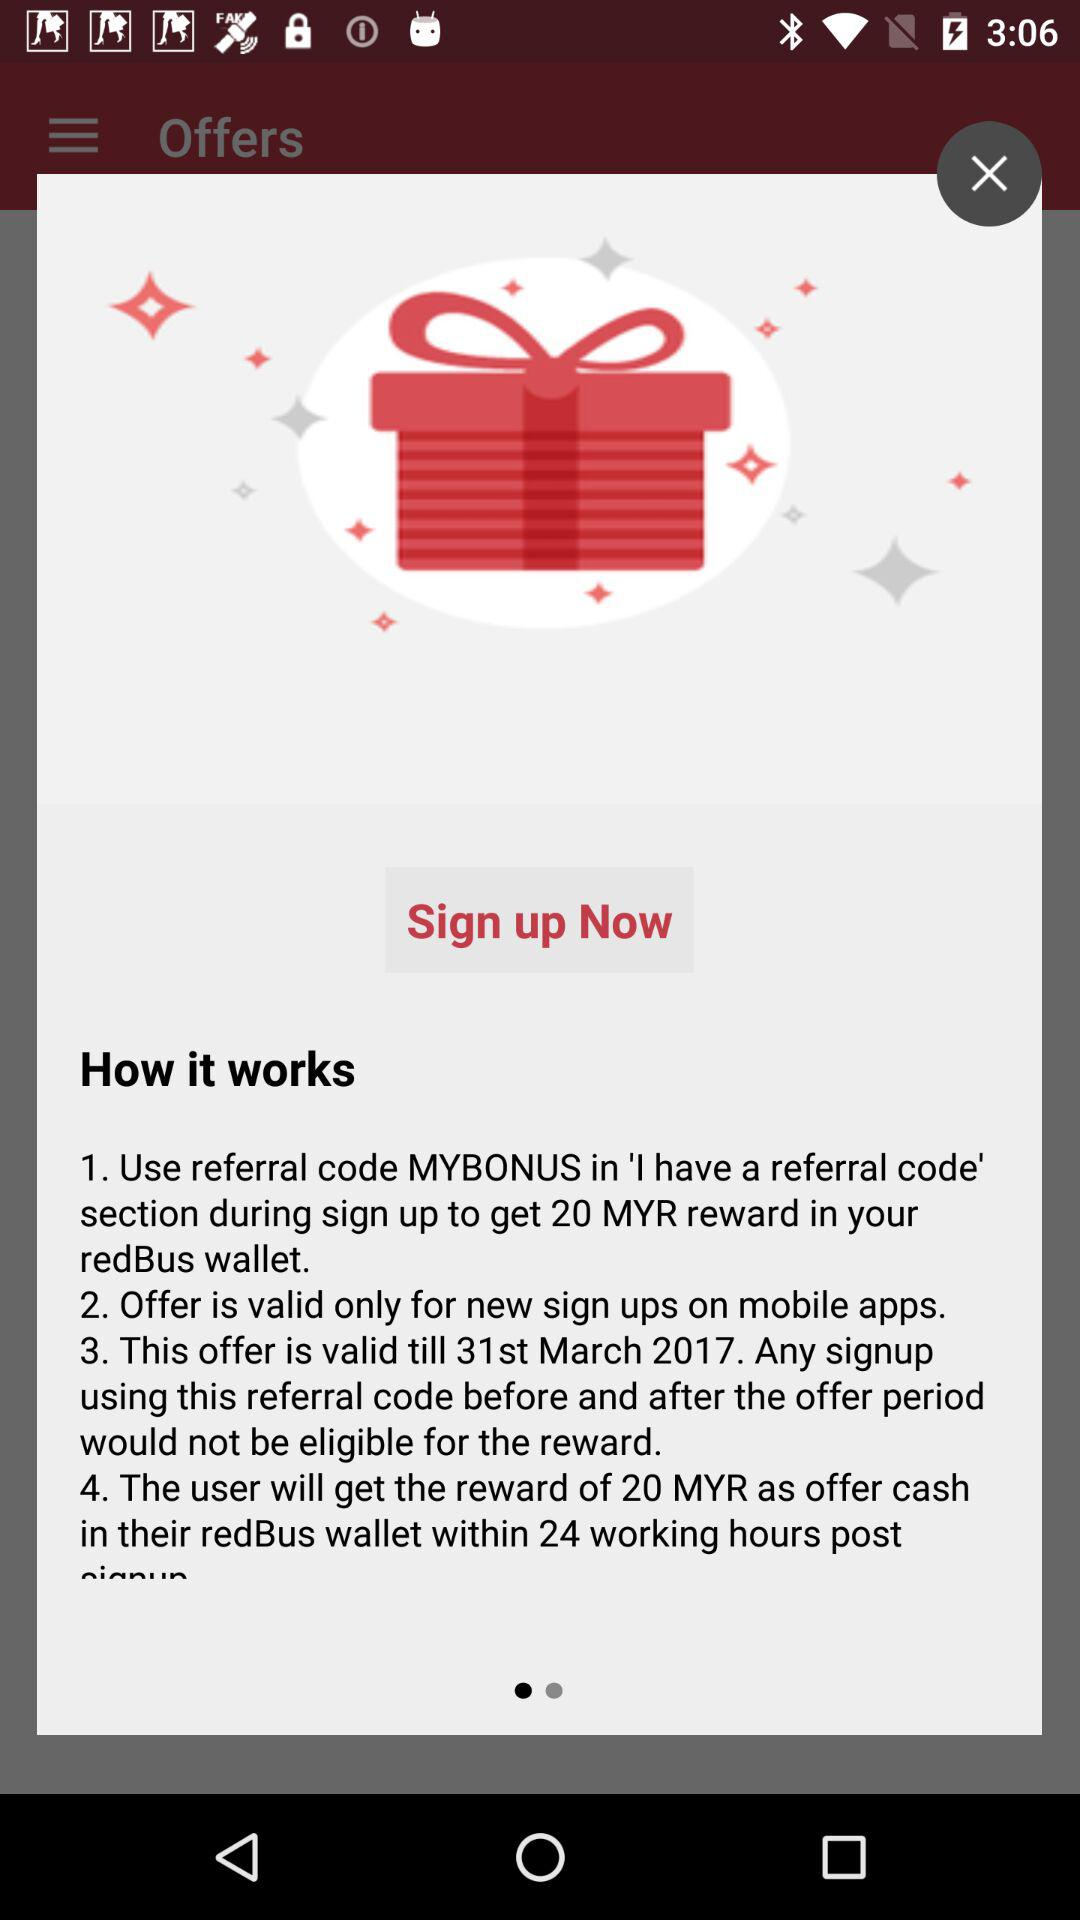What is the referral code? The referral code is "MYBONUS". 